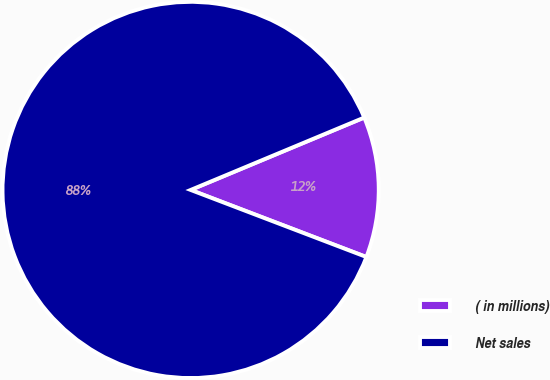Convert chart. <chart><loc_0><loc_0><loc_500><loc_500><pie_chart><fcel>( in millions)<fcel>Net sales<nl><fcel>12.09%<fcel>87.91%<nl></chart> 